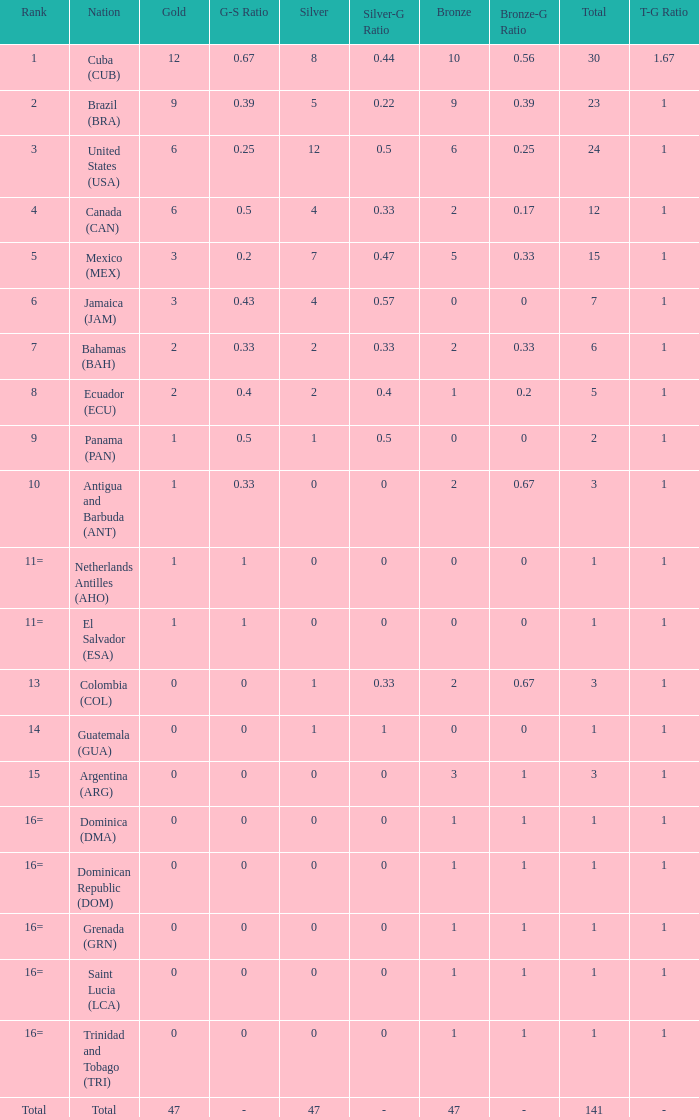What is the total gold with a total less than 1? None. 